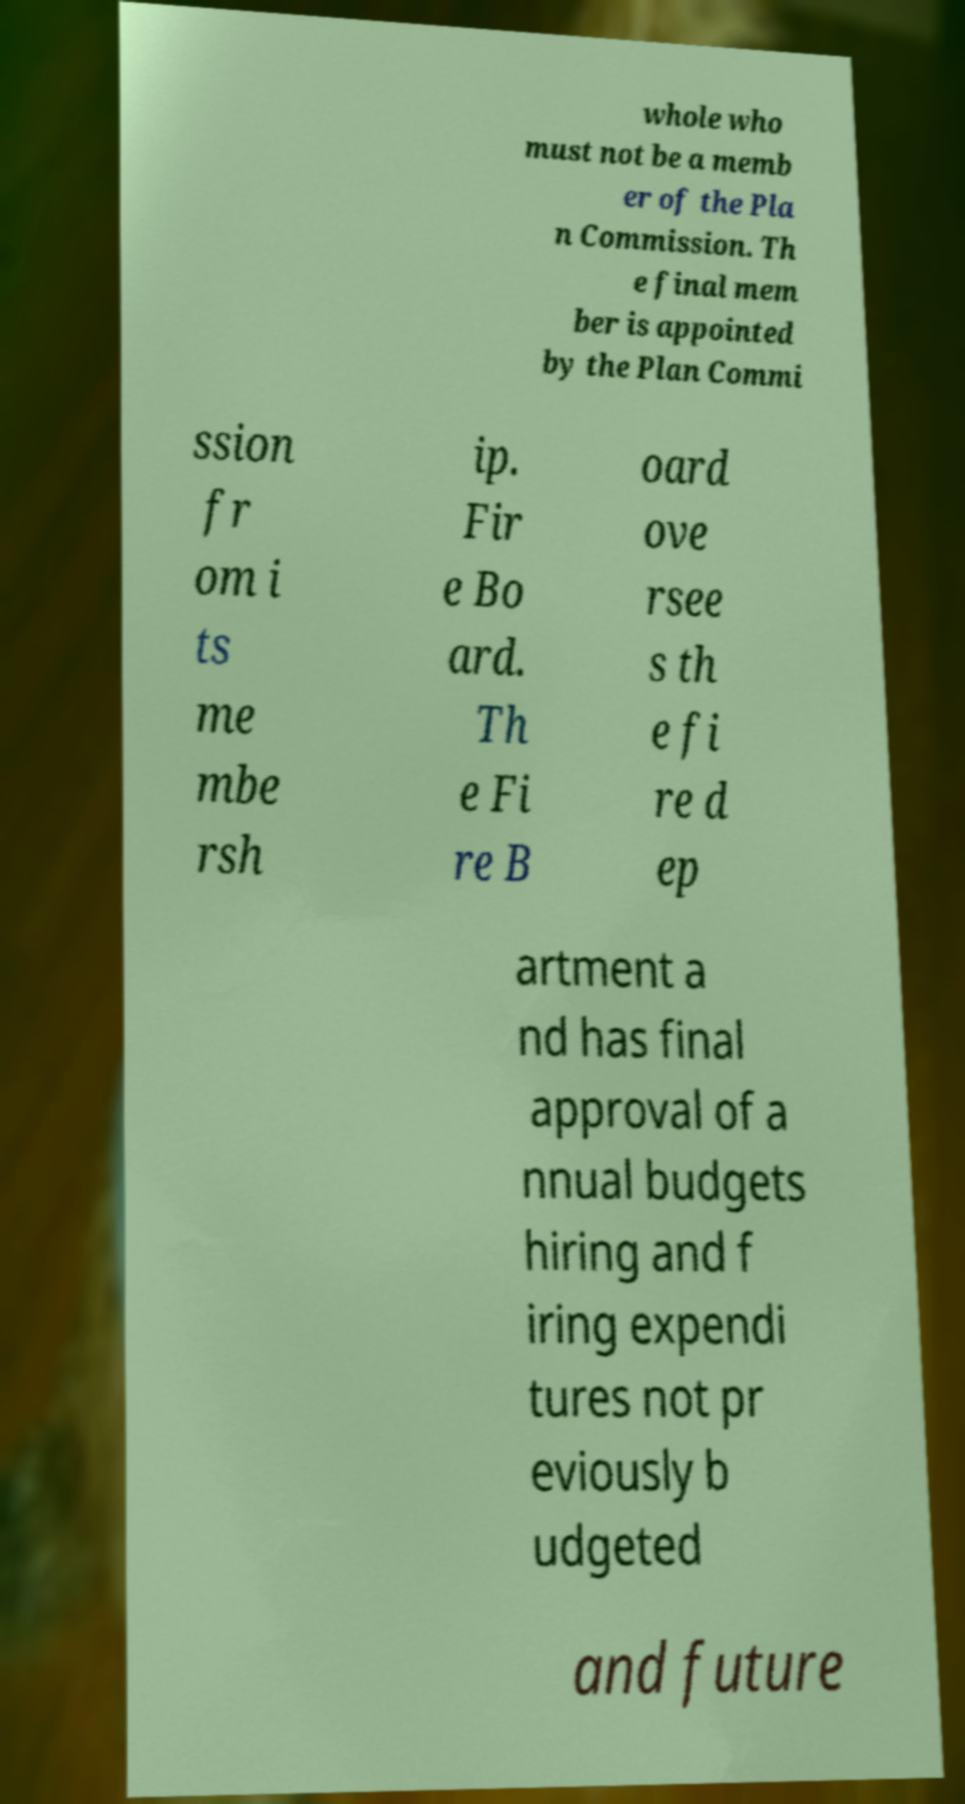Please identify and transcribe the text found in this image. whole who must not be a memb er of the Pla n Commission. Th e final mem ber is appointed by the Plan Commi ssion fr om i ts me mbe rsh ip. Fir e Bo ard. Th e Fi re B oard ove rsee s th e fi re d ep artment a nd has final approval of a nnual budgets hiring and f iring expendi tures not pr eviously b udgeted and future 